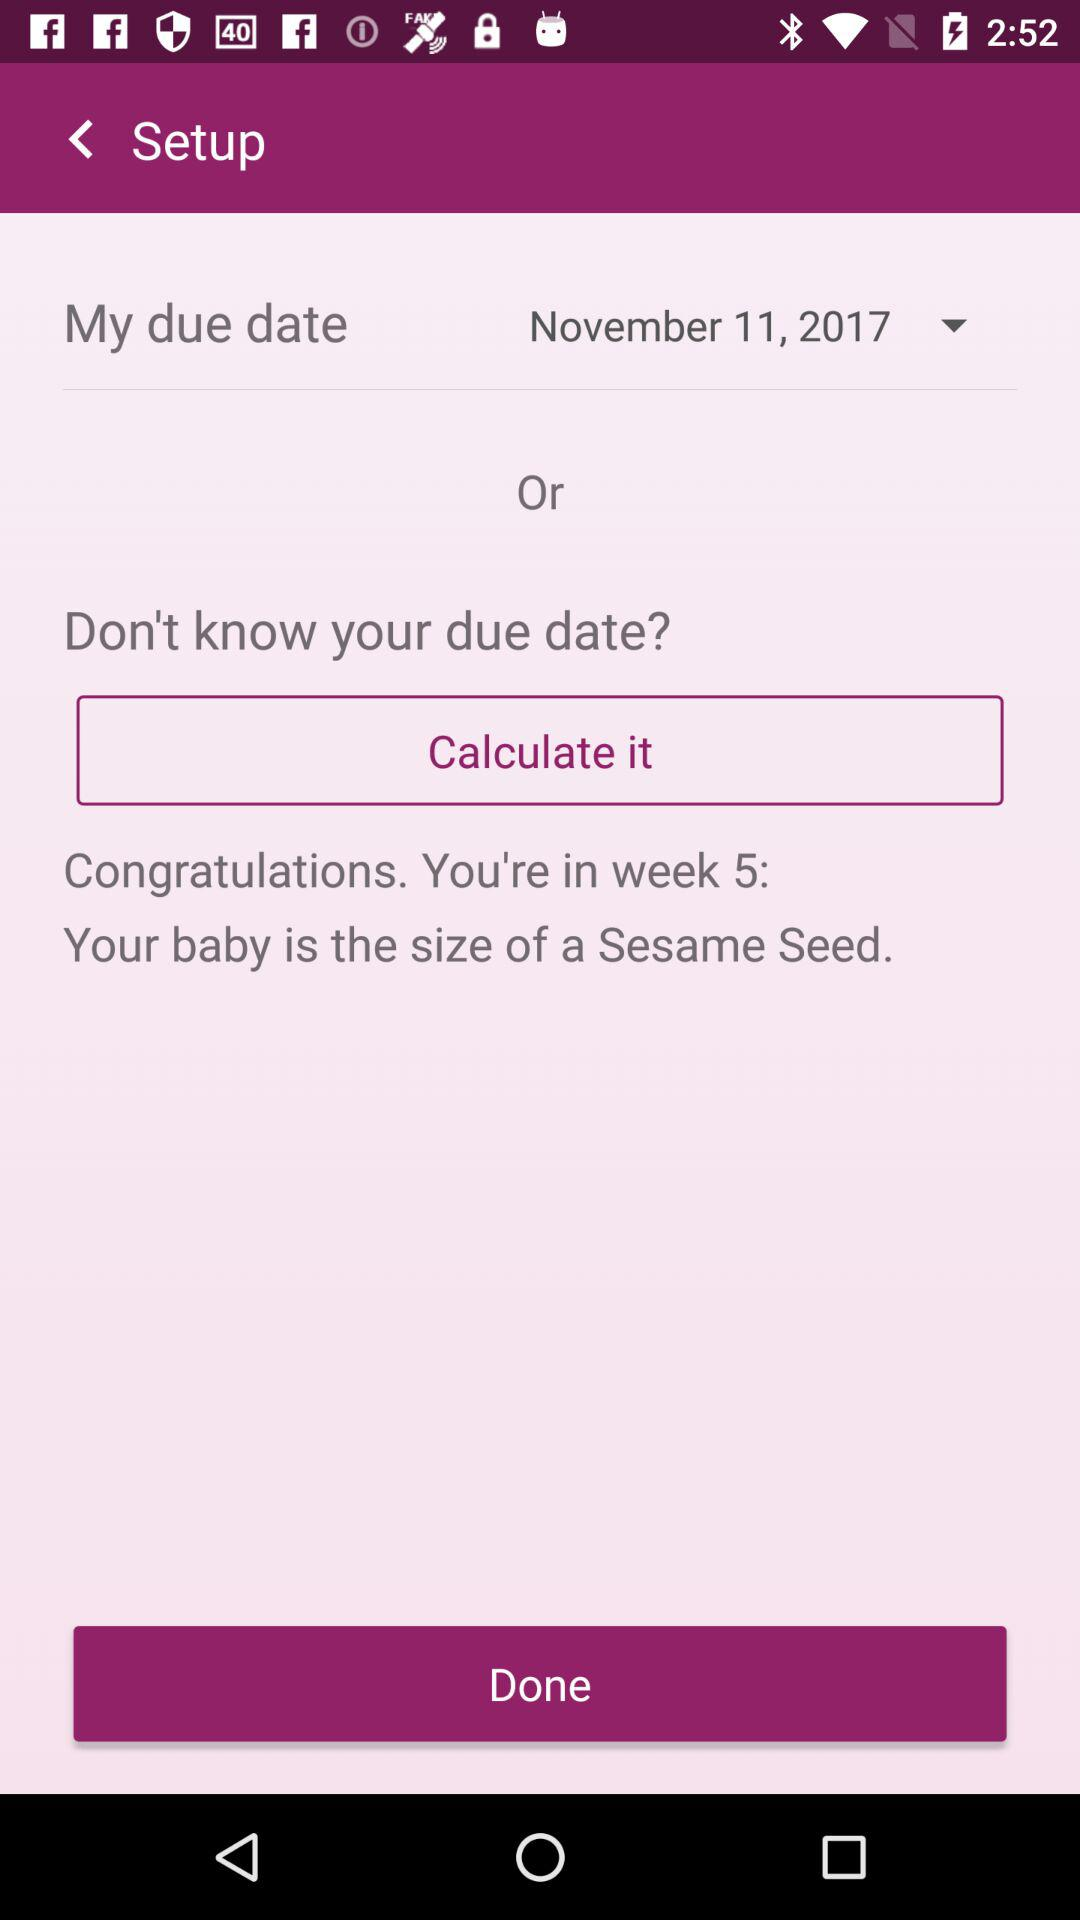How many weeks pregnant is the user?
Answer the question using a single word or phrase. 5 